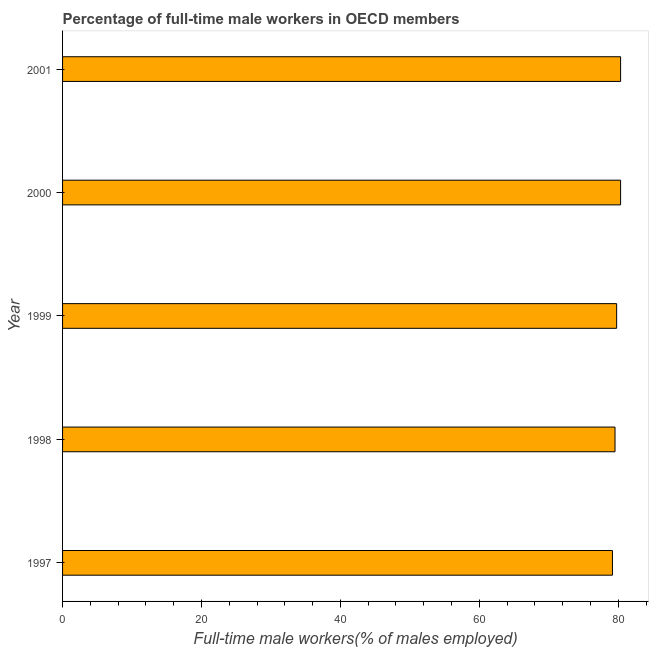Does the graph contain any zero values?
Give a very brief answer. No. Does the graph contain grids?
Give a very brief answer. No. What is the title of the graph?
Provide a short and direct response. Percentage of full-time male workers in OECD members. What is the label or title of the X-axis?
Offer a terse response. Full-time male workers(% of males employed). What is the label or title of the Y-axis?
Your response must be concise. Year. What is the percentage of full-time male workers in 1999?
Give a very brief answer. 79.77. Across all years, what is the maximum percentage of full-time male workers?
Your answer should be very brief. 80.34. Across all years, what is the minimum percentage of full-time male workers?
Keep it short and to the point. 79.17. In which year was the percentage of full-time male workers maximum?
Your answer should be compact. 2001. What is the sum of the percentage of full-time male workers?
Ensure brevity in your answer.  399.16. What is the difference between the percentage of full-time male workers in 2000 and 2001?
Ensure brevity in your answer.  -0. What is the average percentage of full-time male workers per year?
Your answer should be compact. 79.83. What is the median percentage of full-time male workers?
Provide a succinct answer. 79.77. What is the ratio of the percentage of full-time male workers in 1999 to that in 2001?
Your response must be concise. 0.99. Is the percentage of full-time male workers in 1999 less than that in 2000?
Make the answer very short. Yes. Is the difference between the percentage of full-time male workers in 1997 and 1999 greater than the difference between any two years?
Make the answer very short. No. What is the difference between the highest and the second highest percentage of full-time male workers?
Make the answer very short. 0. What is the difference between the highest and the lowest percentage of full-time male workers?
Your answer should be very brief. 1.17. In how many years, is the percentage of full-time male workers greater than the average percentage of full-time male workers taken over all years?
Offer a terse response. 2. Are all the bars in the graph horizontal?
Provide a short and direct response. Yes. How many years are there in the graph?
Your answer should be compact. 5. What is the difference between two consecutive major ticks on the X-axis?
Provide a short and direct response. 20. Are the values on the major ticks of X-axis written in scientific E-notation?
Provide a succinct answer. No. What is the Full-time male workers(% of males employed) of 1997?
Your answer should be very brief. 79.17. What is the Full-time male workers(% of males employed) of 1998?
Your response must be concise. 79.54. What is the Full-time male workers(% of males employed) in 1999?
Your answer should be compact. 79.77. What is the Full-time male workers(% of males employed) in 2000?
Make the answer very short. 80.34. What is the Full-time male workers(% of males employed) of 2001?
Provide a succinct answer. 80.34. What is the difference between the Full-time male workers(% of males employed) in 1997 and 1998?
Your answer should be very brief. -0.37. What is the difference between the Full-time male workers(% of males employed) in 1997 and 1999?
Offer a terse response. -0.6. What is the difference between the Full-time male workers(% of males employed) in 1997 and 2000?
Provide a short and direct response. -1.17. What is the difference between the Full-time male workers(% of males employed) in 1997 and 2001?
Ensure brevity in your answer.  -1.17. What is the difference between the Full-time male workers(% of males employed) in 1998 and 1999?
Offer a terse response. -0.24. What is the difference between the Full-time male workers(% of males employed) in 1998 and 2000?
Keep it short and to the point. -0.8. What is the difference between the Full-time male workers(% of males employed) in 1998 and 2001?
Offer a terse response. -0.8. What is the difference between the Full-time male workers(% of males employed) in 1999 and 2000?
Give a very brief answer. -0.57. What is the difference between the Full-time male workers(% of males employed) in 1999 and 2001?
Give a very brief answer. -0.57. What is the difference between the Full-time male workers(% of males employed) in 2000 and 2001?
Ensure brevity in your answer.  -0. What is the ratio of the Full-time male workers(% of males employed) in 1997 to that in 1998?
Offer a terse response. 0.99. What is the ratio of the Full-time male workers(% of males employed) in 1997 to that in 2000?
Make the answer very short. 0.98. What is the ratio of the Full-time male workers(% of males employed) in 1997 to that in 2001?
Offer a very short reply. 0.98. What is the ratio of the Full-time male workers(% of males employed) in 1998 to that in 1999?
Make the answer very short. 1. What is the ratio of the Full-time male workers(% of males employed) in 1998 to that in 2001?
Your answer should be compact. 0.99. 